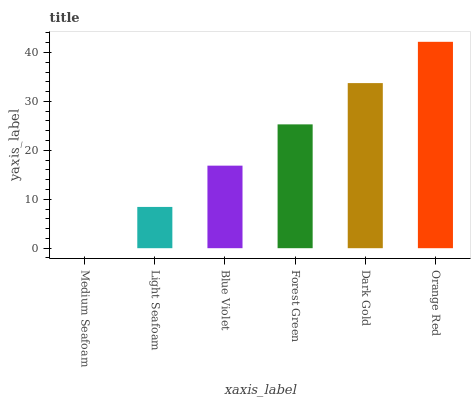Is Medium Seafoam the minimum?
Answer yes or no. Yes. Is Orange Red the maximum?
Answer yes or no. Yes. Is Light Seafoam the minimum?
Answer yes or no. No. Is Light Seafoam the maximum?
Answer yes or no. No. Is Light Seafoam greater than Medium Seafoam?
Answer yes or no. Yes. Is Medium Seafoam less than Light Seafoam?
Answer yes or no. Yes. Is Medium Seafoam greater than Light Seafoam?
Answer yes or no. No. Is Light Seafoam less than Medium Seafoam?
Answer yes or no. No. Is Forest Green the high median?
Answer yes or no. Yes. Is Blue Violet the low median?
Answer yes or no. Yes. Is Light Seafoam the high median?
Answer yes or no. No. Is Forest Green the low median?
Answer yes or no. No. 